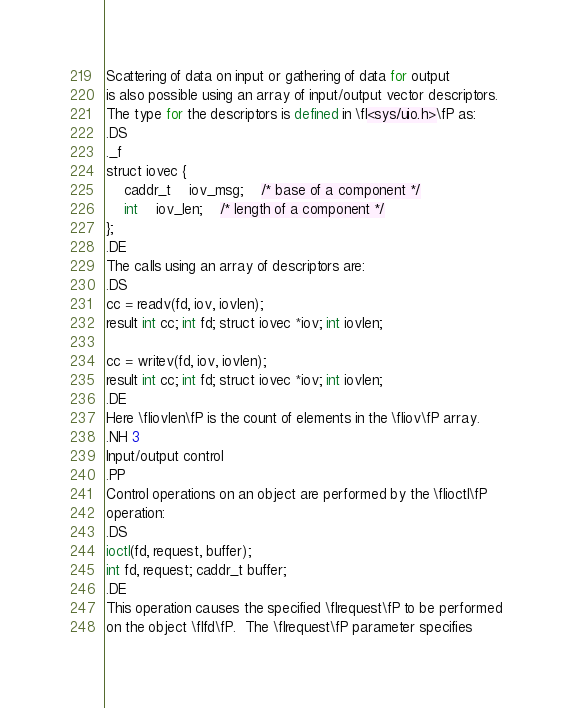Convert code to text. <code><loc_0><loc_0><loc_500><loc_500><_Perl_>Scattering of data on input or gathering of data for output
is also possible using an array of input/output vector descriptors.
The type for the descriptors is defined in \fI<sys/uio.h>\fP as:
.DS
._f
struct iovec {
	caddr_t	iov_msg;	/* base of a component */
	int	iov_len;	/* length of a component */
};
.DE
The calls using an array of descriptors are:
.DS
cc = readv(fd, iov, iovlen);
result int cc; int fd; struct iovec *iov; int iovlen;

cc = writev(fd, iov, iovlen);
result int cc; int fd; struct iovec *iov; int iovlen;
.DE
Here \fIiovlen\fP is the count of elements in the \fIiov\fP array.
.NH 3
Input/output control
.PP
Control operations on an object are performed by the \fIioctl\fP
operation:
.DS
ioctl(fd, request, buffer);
int fd, request; caddr_t buffer;
.DE
This operation causes the specified \fIrequest\fP to be performed
on the object \fIfd\fP.  The \fIrequest\fP parameter specifies</code> 